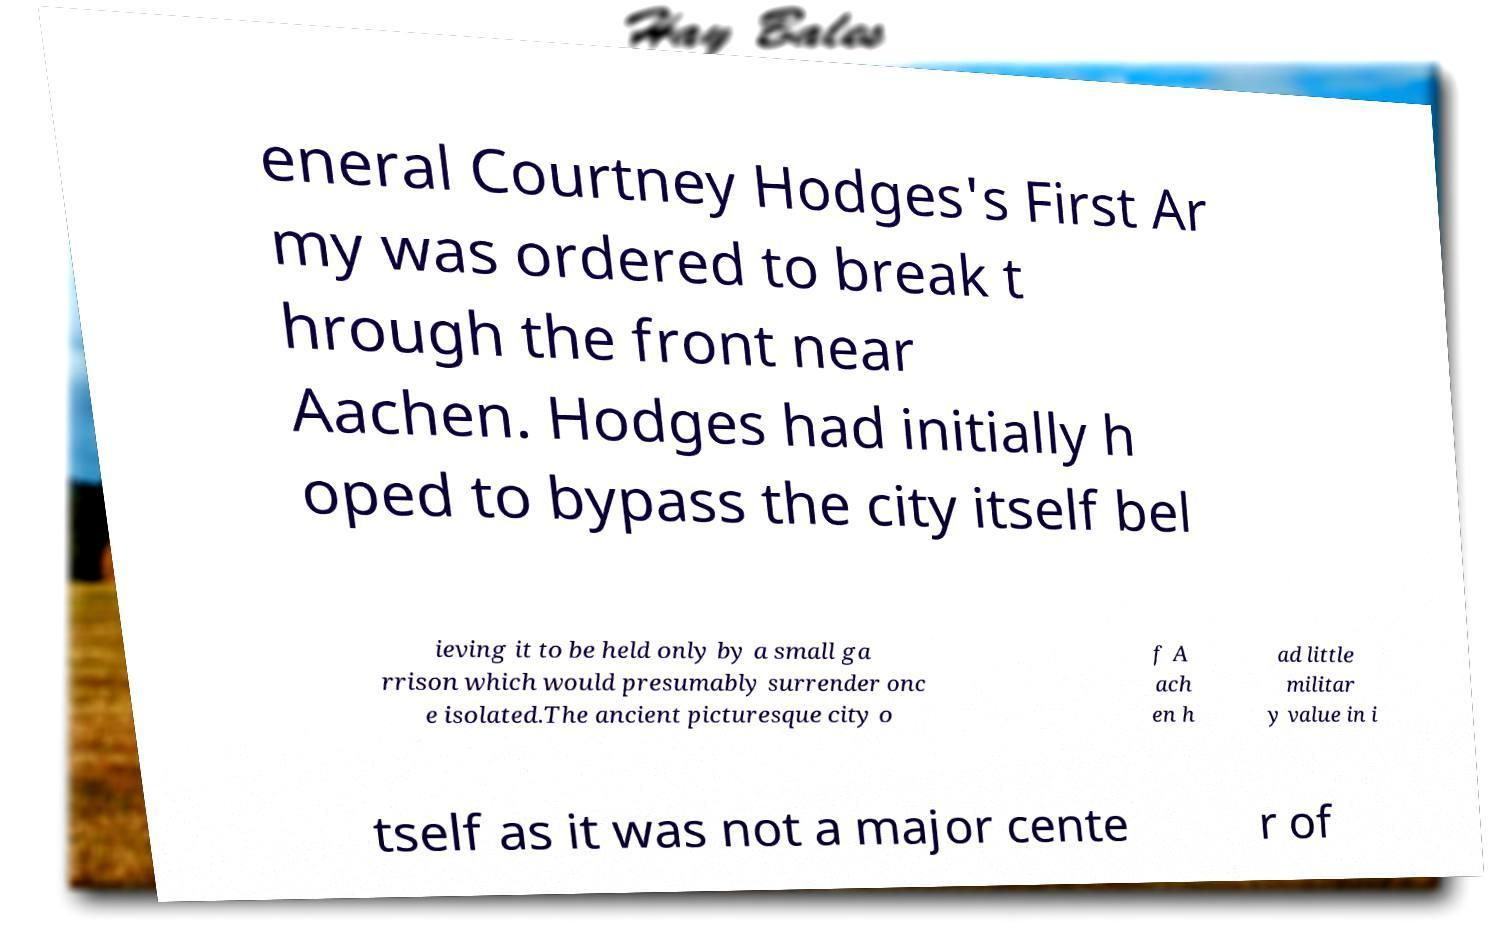Can you read and provide the text displayed in the image?This photo seems to have some interesting text. Can you extract and type it out for me? eneral Courtney Hodges's First Ar my was ordered to break t hrough the front near Aachen. Hodges had initially h oped to bypass the city itself bel ieving it to be held only by a small ga rrison which would presumably surrender onc e isolated.The ancient picturesque city o f A ach en h ad little militar y value in i tself as it was not a major cente r of 